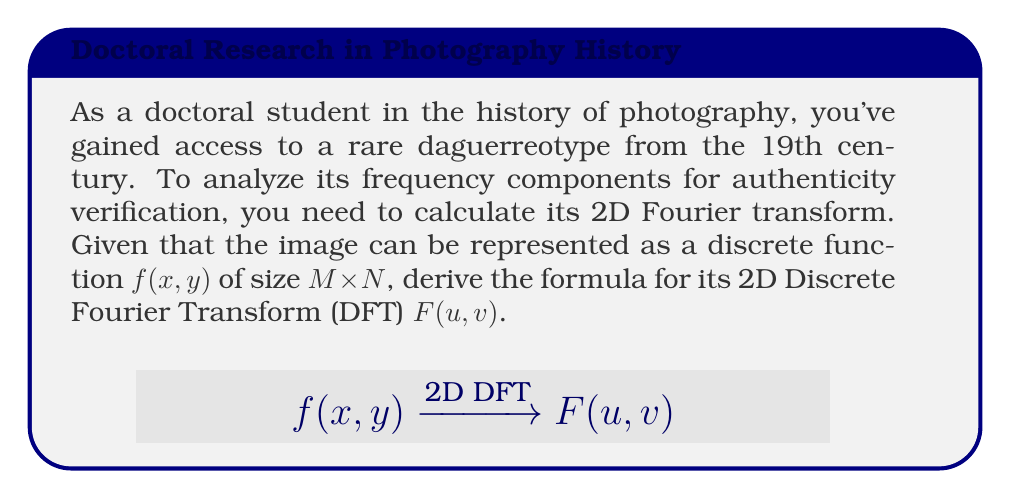Solve this math problem. To calculate the 2D Fourier transform of a photographic image, we follow these steps:

1) The 2D Discrete Fourier Transform (DFT) is an extension of the 1D DFT to two dimensions. For a discrete image function $f(x,y)$ of size $M \times N$, the 2D DFT is defined as:

   $$F(u,v) = \sum_{x=0}^{M-1} \sum_{y=0}^{N-1} f(x,y) e^{-j2\pi(\frac{ux}{M} + \frac{vy}{N})}$$

   where:
   - $f(x,y)$ is the image pixel value at coordinates $(x,y)$
   - $F(u,v)$ is the Fourier coefficient at frequencies $(u,v)$
   - $M$ and $N$ are the image dimensions
   - $j$ is the imaginary unit

2) The exponential term can be separated:

   $$F(u,v) = \sum_{x=0}^{M-1} \sum_{y=0}^{N-1} f(x,y) e^{-j2\pi\frac{ux}{M}} e^{-j2\pi\frac{vy}{N}}$$

3) This formula calculates the frequency components $F(u,v)$ for each frequency pair $(u,v)$, where $u = 0,1,...,M-1$ and $v = 0,1,...,N-1$.

4) The result $F(u,v)$ is a complex-valued function representing the magnitude and phase of different frequency components in the image.

5) In practice, Fast Fourier Transform (FFT) algorithms are used to compute the DFT efficiently.
Answer: $$F(u,v) = \sum_{x=0}^{M-1} \sum_{y=0}^{N-1} f(x,y) e^{-j2\pi(\frac{ux}{M} + \frac{vy}{N})}$$ 